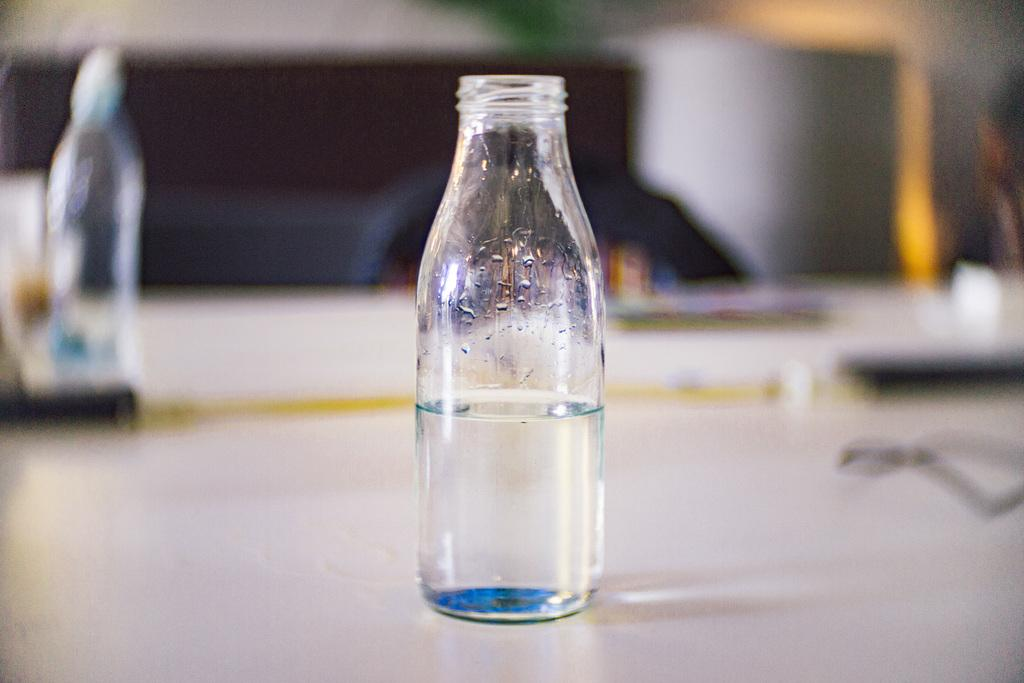What is inside the glass bottle that is visible in the image? There is a glass bottle filled with liquid in the image. Where is the glass bottle located in the image? The glass bottle is placed on a table. Can you see any other glass bottles in the image? Yes, there is another glass bottle in the background of the image. What type of toy is being played with in the image? There is no toy or play activity depicted in the image; it only shows glass bottles. 